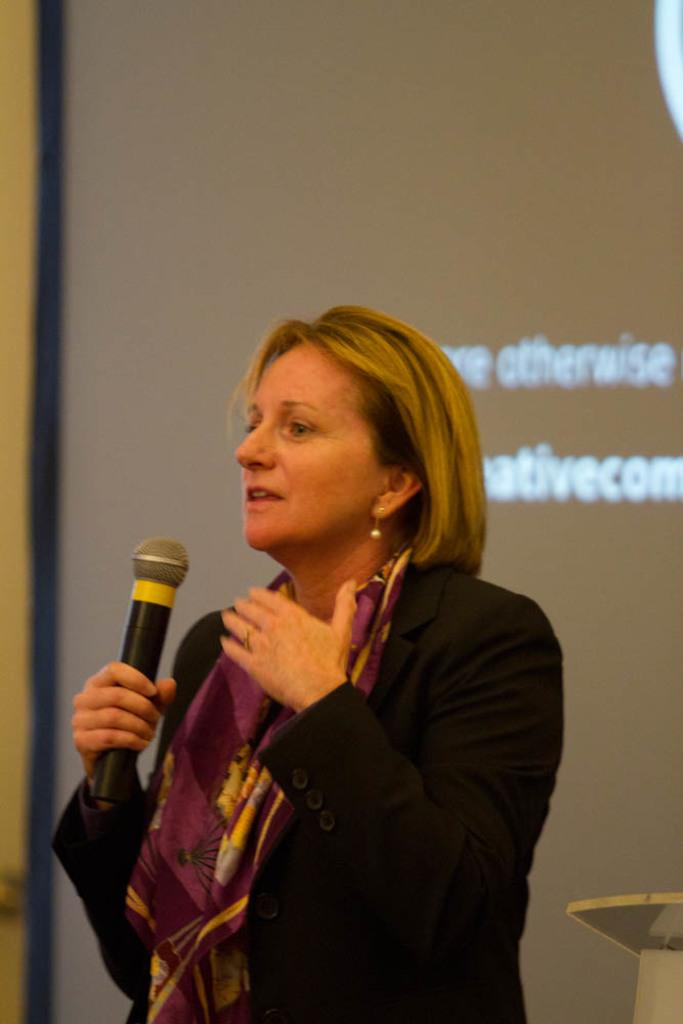Who is present in the image? There is a woman in the image. What is the woman wearing? The woman is wearing a black coat. What can be seen on the wall in the background of the image? There is a screen on the wall in the background of the image. What type of riddle is the woman trying to solve in the image? There is no riddle present in the image, and the woman is not attempting to solve one. 